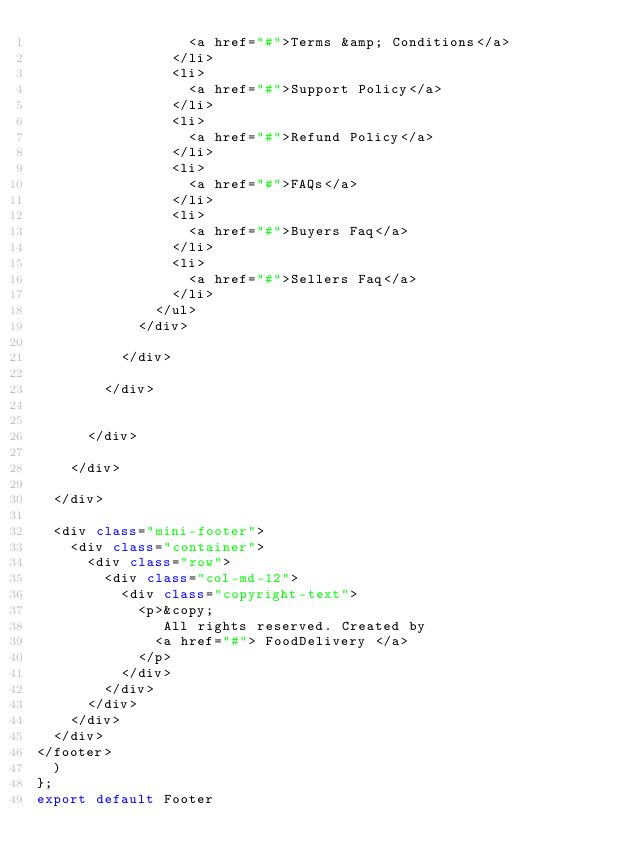<code> <loc_0><loc_0><loc_500><loc_500><_JavaScript_>                  <a href="#">Terms &amp; Conditions</a>
                </li>
                <li>
                  <a href="#">Support Policy</a>
                </li>
                <li>
                  <a href="#">Refund Policy</a>
                </li>
                <li>
                  <a href="#">FAQs</a>
                </li>
                <li>
                  <a href="#">Buyers Faq</a>
                </li>
                <li>
                  <a href="#">Sellers Faq</a>
                </li>
              </ul>
            </div>
         
          </div>
        
        </div>
      

      </div>
     
    </div>

  </div>

  <div class="mini-footer">
    <div class="container">
      <div class="row">
        <div class="col-md-12">
          <div class="copyright-text">
            <p>&copy;
               All rights reserved. Created by
              <a href="#"> FoodDelivery </a>
            </p>
          </div>
        </div>
      </div>
    </div>
  </div>
</footer>
  )
};
export default Footer</code> 